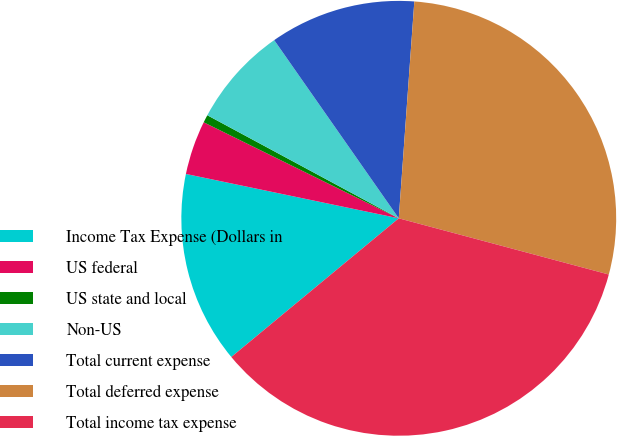<chart> <loc_0><loc_0><loc_500><loc_500><pie_chart><fcel>Income Tax Expense (Dollars in<fcel>US federal<fcel>US state and local<fcel>Non-US<fcel>Total current expense<fcel>Total deferred expense<fcel>Total income tax expense<nl><fcel>14.28%<fcel>4.01%<fcel>0.58%<fcel>7.43%<fcel>10.85%<fcel>28.02%<fcel>34.83%<nl></chart> 